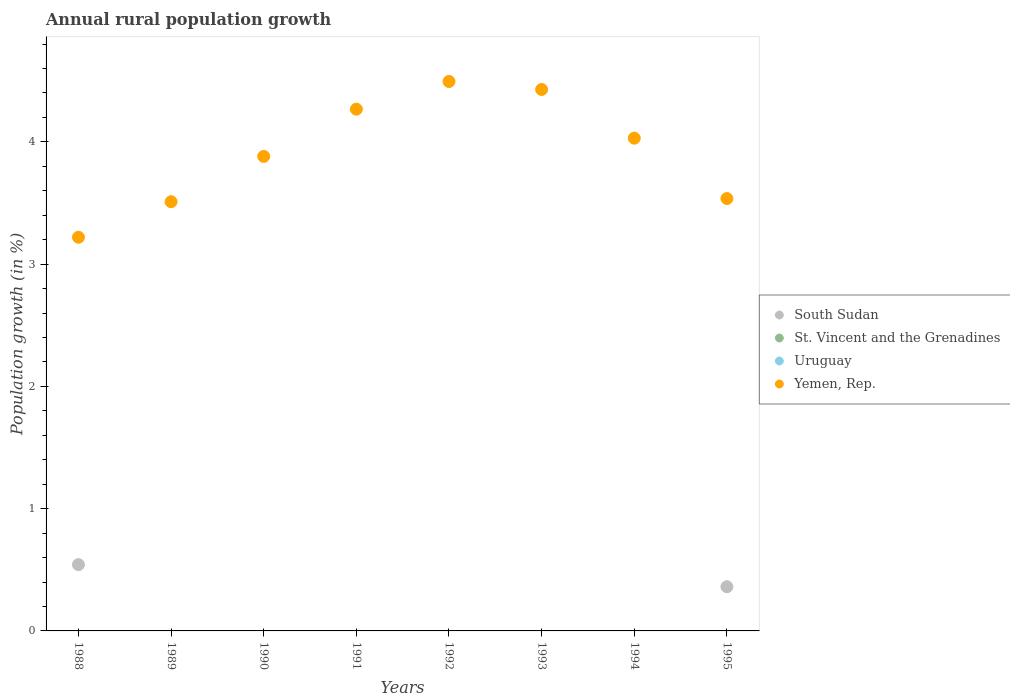How many different coloured dotlines are there?
Provide a short and direct response. 2. Is the number of dotlines equal to the number of legend labels?
Offer a terse response. No. Across all years, what is the maximum percentage of rural population growth in South Sudan?
Ensure brevity in your answer.  0.54. What is the difference between the percentage of rural population growth in Yemen, Rep. in 1988 and that in 1994?
Provide a succinct answer. -0.81. What is the difference between the percentage of rural population growth in Uruguay in 1993 and the percentage of rural population growth in St. Vincent and the Grenadines in 1991?
Provide a succinct answer. 0. What is the average percentage of rural population growth in Uruguay per year?
Offer a terse response. 0. In the year 1995, what is the difference between the percentage of rural population growth in South Sudan and percentage of rural population growth in Yemen, Rep.?
Provide a succinct answer. -3.17. What is the difference between the highest and the second highest percentage of rural population growth in Yemen, Rep.?
Ensure brevity in your answer.  0.07. What is the difference between the highest and the lowest percentage of rural population growth in South Sudan?
Your response must be concise. 0.54. In how many years, is the percentage of rural population growth in St. Vincent and the Grenadines greater than the average percentage of rural population growth in St. Vincent and the Grenadines taken over all years?
Your answer should be compact. 0. Is the sum of the percentage of rural population growth in Yemen, Rep. in 1994 and 1995 greater than the maximum percentage of rural population growth in St. Vincent and the Grenadines across all years?
Your response must be concise. Yes. Is it the case that in every year, the sum of the percentage of rural population growth in St. Vincent and the Grenadines and percentage of rural population growth in Yemen, Rep.  is greater than the sum of percentage of rural population growth in Uruguay and percentage of rural population growth in South Sudan?
Provide a short and direct response. No. Is it the case that in every year, the sum of the percentage of rural population growth in St. Vincent and the Grenadines and percentage of rural population growth in South Sudan  is greater than the percentage of rural population growth in Yemen, Rep.?
Ensure brevity in your answer.  No. How many legend labels are there?
Offer a very short reply. 4. How are the legend labels stacked?
Offer a very short reply. Vertical. What is the title of the graph?
Provide a succinct answer. Annual rural population growth. What is the label or title of the Y-axis?
Your answer should be compact. Population growth (in %). What is the Population growth (in %) in South Sudan in 1988?
Make the answer very short. 0.54. What is the Population growth (in %) in St. Vincent and the Grenadines in 1988?
Your response must be concise. 0. What is the Population growth (in %) of Yemen, Rep. in 1988?
Provide a short and direct response. 3.22. What is the Population growth (in %) in South Sudan in 1989?
Offer a very short reply. 0. What is the Population growth (in %) in St. Vincent and the Grenadines in 1989?
Ensure brevity in your answer.  0. What is the Population growth (in %) in Uruguay in 1989?
Make the answer very short. 0. What is the Population growth (in %) of Yemen, Rep. in 1989?
Your answer should be compact. 3.51. What is the Population growth (in %) of St. Vincent and the Grenadines in 1990?
Offer a terse response. 0. What is the Population growth (in %) of Yemen, Rep. in 1990?
Your answer should be very brief. 3.88. What is the Population growth (in %) in South Sudan in 1991?
Give a very brief answer. 0. What is the Population growth (in %) of St. Vincent and the Grenadines in 1991?
Your response must be concise. 0. What is the Population growth (in %) of Uruguay in 1991?
Offer a terse response. 0. What is the Population growth (in %) in Yemen, Rep. in 1991?
Ensure brevity in your answer.  4.27. What is the Population growth (in %) of Uruguay in 1992?
Your answer should be very brief. 0. What is the Population growth (in %) in Yemen, Rep. in 1992?
Make the answer very short. 4.49. What is the Population growth (in %) of Uruguay in 1993?
Give a very brief answer. 0. What is the Population growth (in %) of Yemen, Rep. in 1993?
Keep it short and to the point. 4.43. What is the Population growth (in %) of Uruguay in 1994?
Offer a very short reply. 0. What is the Population growth (in %) in Yemen, Rep. in 1994?
Ensure brevity in your answer.  4.03. What is the Population growth (in %) of South Sudan in 1995?
Keep it short and to the point. 0.36. What is the Population growth (in %) in Uruguay in 1995?
Provide a succinct answer. 0. What is the Population growth (in %) in Yemen, Rep. in 1995?
Give a very brief answer. 3.54. Across all years, what is the maximum Population growth (in %) in South Sudan?
Offer a very short reply. 0.54. Across all years, what is the maximum Population growth (in %) of Yemen, Rep.?
Ensure brevity in your answer.  4.49. Across all years, what is the minimum Population growth (in %) in Yemen, Rep.?
Your answer should be very brief. 3.22. What is the total Population growth (in %) in South Sudan in the graph?
Provide a short and direct response. 0.9. What is the total Population growth (in %) in Uruguay in the graph?
Your response must be concise. 0. What is the total Population growth (in %) of Yemen, Rep. in the graph?
Offer a very short reply. 31.36. What is the difference between the Population growth (in %) of Yemen, Rep. in 1988 and that in 1989?
Provide a short and direct response. -0.29. What is the difference between the Population growth (in %) of Yemen, Rep. in 1988 and that in 1990?
Give a very brief answer. -0.66. What is the difference between the Population growth (in %) of Yemen, Rep. in 1988 and that in 1991?
Ensure brevity in your answer.  -1.05. What is the difference between the Population growth (in %) in Yemen, Rep. in 1988 and that in 1992?
Ensure brevity in your answer.  -1.27. What is the difference between the Population growth (in %) of Yemen, Rep. in 1988 and that in 1993?
Offer a terse response. -1.21. What is the difference between the Population growth (in %) in Yemen, Rep. in 1988 and that in 1994?
Your response must be concise. -0.81. What is the difference between the Population growth (in %) in South Sudan in 1988 and that in 1995?
Offer a terse response. 0.18. What is the difference between the Population growth (in %) in Yemen, Rep. in 1988 and that in 1995?
Your answer should be compact. -0.32. What is the difference between the Population growth (in %) in Yemen, Rep. in 1989 and that in 1990?
Offer a very short reply. -0.37. What is the difference between the Population growth (in %) in Yemen, Rep. in 1989 and that in 1991?
Your answer should be compact. -0.76. What is the difference between the Population growth (in %) in Yemen, Rep. in 1989 and that in 1992?
Provide a short and direct response. -0.98. What is the difference between the Population growth (in %) in Yemen, Rep. in 1989 and that in 1993?
Your response must be concise. -0.92. What is the difference between the Population growth (in %) of Yemen, Rep. in 1989 and that in 1994?
Provide a short and direct response. -0.52. What is the difference between the Population growth (in %) in Yemen, Rep. in 1989 and that in 1995?
Offer a terse response. -0.03. What is the difference between the Population growth (in %) in Yemen, Rep. in 1990 and that in 1991?
Keep it short and to the point. -0.39. What is the difference between the Population growth (in %) in Yemen, Rep. in 1990 and that in 1992?
Offer a terse response. -0.61. What is the difference between the Population growth (in %) in Yemen, Rep. in 1990 and that in 1993?
Your answer should be very brief. -0.55. What is the difference between the Population growth (in %) in Yemen, Rep. in 1990 and that in 1994?
Provide a short and direct response. -0.15. What is the difference between the Population growth (in %) of Yemen, Rep. in 1990 and that in 1995?
Your answer should be very brief. 0.34. What is the difference between the Population growth (in %) in Yemen, Rep. in 1991 and that in 1992?
Offer a very short reply. -0.23. What is the difference between the Population growth (in %) of Yemen, Rep. in 1991 and that in 1993?
Your answer should be very brief. -0.16. What is the difference between the Population growth (in %) in Yemen, Rep. in 1991 and that in 1994?
Give a very brief answer. 0.24. What is the difference between the Population growth (in %) of Yemen, Rep. in 1991 and that in 1995?
Your response must be concise. 0.73. What is the difference between the Population growth (in %) in Yemen, Rep. in 1992 and that in 1993?
Your answer should be compact. 0.07. What is the difference between the Population growth (in %) in Yemen, Rep. in 1992 and that in 1994?
Keep it short and to the point. 0.46. What is the difference between the Population growth (in %) in Yemen, Rep. in 1992 and that in 1995?
Your answer should be compact. 0.96. What is the difference between the Population growth (in %) of Yemen, Rep. in 1993 and that in 1994?
Provide a short and direct response. 0.4. What is the difference between the Population growth (in %) of Yemen, Rep. in 1993 and that in 1995?
Offer a very short reply. 0.89. What is the difference between the Population growth (in %) in Yemen, Rep. in 1994 and that in 1995?
Ensure brevity in your answer.  0.49. What is the difference between the Population growth (in %) of South Sudan in 1988 and the Population growth (in %) of Yemen, Rep. in 1989?
Your answer should be compact. -2.97. What is the difference between the Population growth (in %) in South Sudan in 1988 and the Population growth (in %) in Yemen, Rep. in 1990?
Offer a very short reply. -3.34. What is the difference between the Population growth (in %) in South Sudan in 1988 and the Population growth (in %) in Yemen, Rep. in 1991?
Offer a terse response. -3.73. What is the difference between the Population growth (in %) in South Sudan in 1988 and the Population growth (in %) in Yemen, Rep. in 1992?
Give a very brief answer. -3.95. What is the difference between the Population growth (in %) in South Sudan in 1988 and the Population growth (in %) in Yemen, Rep. in 1993?
Offer a very short reply. -3.89. What is the difference between the Population growth (in %) of South Sudan in 1988 and the Population growth (in %) of Yemen, Rep. in 1994?
Make the answer very short. -3.49. What is the difference between the Population growth (in %) of South Sudan in 1988 and the Population growth (in %) of Yemen, Rep. in 1995?
Your answer should be compact. -2.99. What is the average Population growth (in %) of South Sudan per year?
Make the answer very short. 0.11. What is the average Population growth (in %) of St. Vincent and the Grenadines per year?
Offer a terse response. 0. What is the average Population growth (in %) of Uruguay per year?
Offer a very short reply. 0. What is the average Population growth (in %) of Yemen, Rep. per year?
Provide a succinct answer. 3.92. In the year 1988, what is the difference between the Population growth (in %) of South Sudan and Population growth (in %) of Yemen, Rep.?
Your answer should be compact. -2.68. In the year 1995, what is the difference between the Population growth (in %) in South Sudan and Population growth (in %) in Yemen, Rep.?
Give a very brief answer. -3.17. What is the ratio of the Population growth (in %) in Yemen, Rep. in 1988 to that in 1989?
Your answer should be very brief. 0.92. What is the ratio of the Population growth (in %) in Yemen, Rep. in 1988 to that in 1990?
Give a very brief answer. 0.83. What is the ratio of the Population growth (in %) in Yemen, Rep. in 1988 to that in 1991?
Your answer should be very brief. 0.75. What is the ratio of the Population growth (in %) of Yemen, Rep. in 1988 to that in 1992?
Make the answer very short. 0.72. What is the ratio of the Population growth (in %) of Yemen, Rep. in 1988 to that in 1993?
Keep it short and to the point. 0.73. What is the ratio of the Population growth (in %) of Yemen, Rep. in 1988 to that in 1994?
Give a very brief answer. 0.8. What is the ratio of the Population growth (in %) in South Sudan in 1988 to that in 1995?
Your answer should be compact. 1.5. What is the ratio of the Population growth (in %) in Yemen, Rep. in 1988 to that in 1995?
Your answer should be very brief. 0.91. What is the ratio of the Population growth (in %) of Yemen, Rep. in 1989 to that in 1990?
Your answer should be very brief. 0.9. What is the ratio of the Population growth (in %) in Yemen, Rep. in 1989 to that in 1991?
Keep it short and to the point. 0.82. What is the ratio of the Population growth (in %) of Yemen, Rep. in 1989 to that in 1992?
Provide a succinct answer. 0.78. What is the ratio of the Population growth (in %) in Yemen, Rep. in 1989 to that in 1993?
Keep it short and to the point. 0.79. What is the ratio of the Population growth (in %) in Yemen, Rep. in 1989 to that in 1994?
Make the answer very short. 0.87. What is the ratio of the Population growth (in %) in Yemen, Rep. in 1989 to that in 1995?
Your answer should be compact. 0.99. What is the ratio of the Population growth (in %) of Yemen, Rep. in 1990 to that in 1991?
Your response must be concise. 0.91. What is the ratio of the Population growth (in %) of Yemen, Rep. in 1990 to that in 1992?
Provide a succinct answer. 0.86. What is the ratio of the Population growth (in %) in Yemen, Rep. in 1990 to that in 1993?
Your answer should be compact. 0.88. What is the ratio of the Population growth (in %) in Yemen, Rep. in 1990 to that in 1994?
Your answer should be compact. 0.96. What is the ratio of the Population growth (in %) in Yemen, Rep. in 1990 to that in 1995?
Your answer should be very brief. 1.1. What is the ratio of the Population growth (in %) in Yemen, Rep. in 1991 to that in 1992?
Offer a very short reply. 0.95. What is the ratio of the Population growth (in %) of Yemen, Rep. in 1991 to that in 1993?
Offer a very short reply. 0.96. What is the ratio of the Population growth (in %) in Yemen, Rep. in 1991 to that in 1994?
Keep it short and to the point. 1.06. What is the ratio of the Population growth (in %) of Yemen, Rep. in 1991 to that in 1995?
Make the answer very short. 1.21. What is the ratio of the Population growth (in %) in Yemen, Rep. in 1992 to that in 1993?
Offer a very short reply. 1.01. What is the ratio of the Population growth (in %) of Yemen, Rep. in 1992 to that in 1994?
Your answer should be very brief. 1.12. What is the ratio of the Population growth (in %) of Yemen, Rep. in 1992 to that in 1995?
Provide a short and direct response. 1.27. What is the ratio of the Population growth (in %) in Yemen, Rep. in 1993 to that in 1994?
Keep it short and to the point. 1.1. What is the ratio of the Population growth (in %) of Yemen, Rep. in 1993 to that in 1995?
Your response must be concise. 1.25. What is the ratio of the Population growth (in %) of Yemen, Rep. in 1994 to that in 1995?
Keep it short and to the point. 1.14. What is the difference between the highest and the second highest Population growth (in %) of Yemen, Rep.?
Your response must be concise. 0.07. What is the difference between the highest and the lowest Population growth (in %) of South Sudan?
Offer a terse response. 0.54. What is the difference between the highest and the lowest Population growth (in %) in Yemen, Rep.?
Your answer should be very brief. 1.27. 